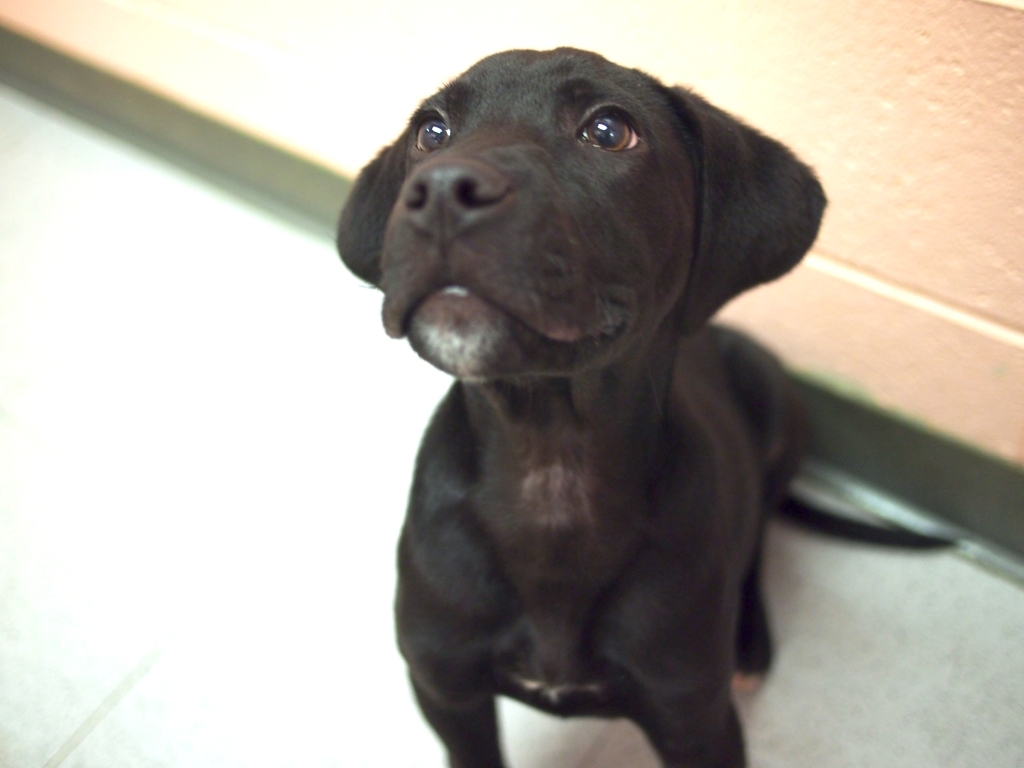Where might this photo have been taken? The background is quite bare and uniform, suggesting an indoor setting, possibly a veterinary clinic or a shelter given the sterile appearance of the walls and the floor. What do you imagine the puppy is looking at? The puppy seems to be gazing upward at someone or something out of view, likely a person, given the engaged and expectant expression. It might be responding to a call or awaiting a treat or command. 